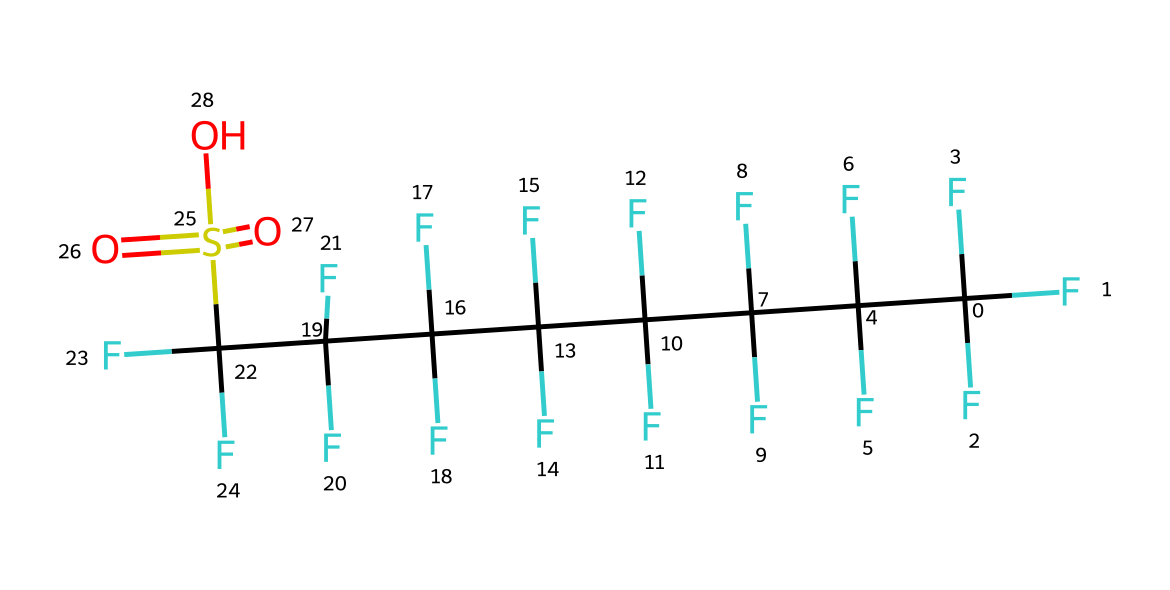What is the total number of carbon atoms in this chemical? Analyzing the SMILES, we see that there are multiple instances of 'C' that represent carbon atoms. Counting them yields eight carbon atoms in total.
Answer: eight How many sulfur atoms are in this chemical? The SMILES contains one occurrence of 'S', indicating that there is one sulfur atom present in the structure.
Answer: one What functional group is present in this fluorosurfactant? The SMILES shows a 'S(=O)(=O)O' portion, which indicates a sulfonic acid functional group (-SO3H) present in the molecule.
Answer: sulfonic acid What is the molecular arrangement of this surfactant classified as? The chemical structure displays a long hydrophobic carbon chain (due to fluorinated carbons) and a hydrophilic sulfonate head, which is characteristic of fluorosurfactants.
Answer: amphiphilic How many fluorine atoms are in this chemical? Each 'F' in the SMILES represents a fluorine atom, and there are a total of 16 fluorine atoms around the carbon backbone.
Answer: sixteen Which characteristic of this fluorosurfactant contributes to its effectiveness in firefighting foams? The highly fluorinated carbon chain enhances its ability to repel water while reducing the surface tension, making it effective in forming stable films in firefighting applications.
Answer: low surface tension 